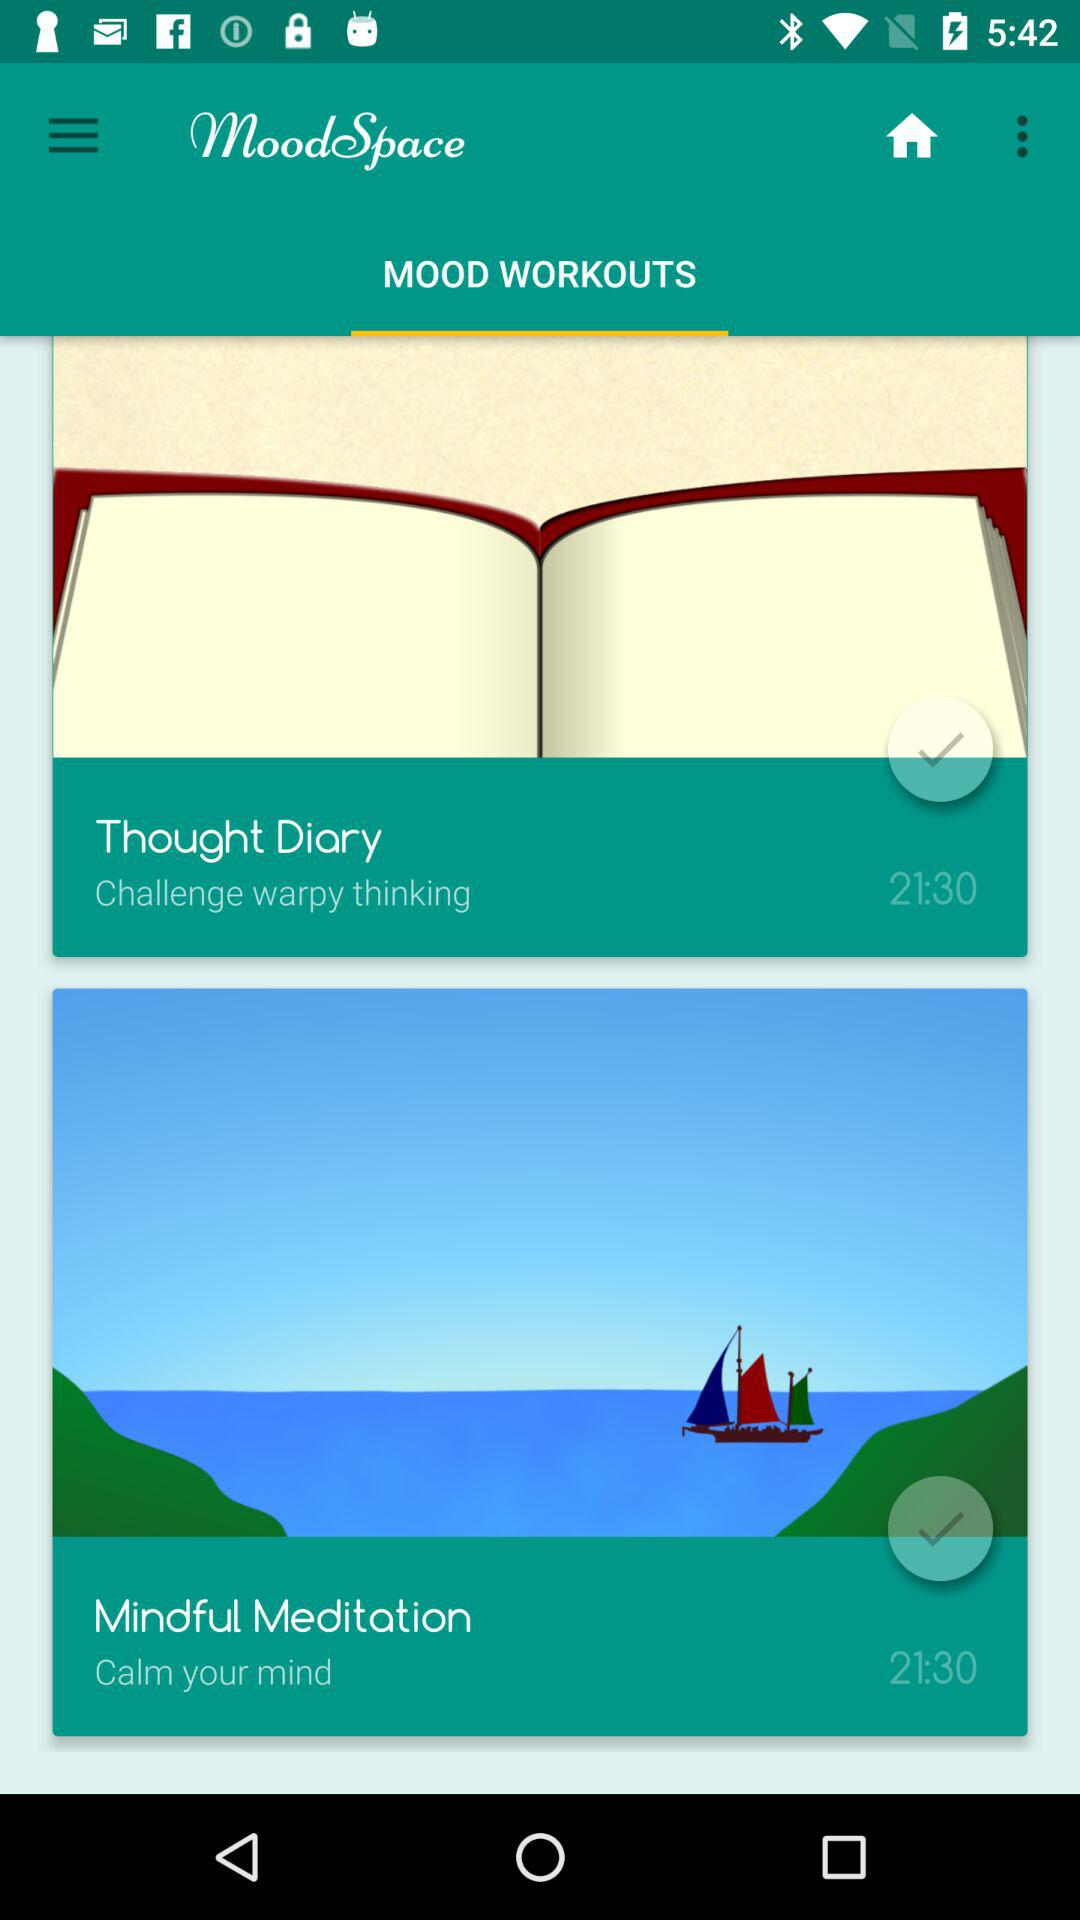What is the given timing? The given timing is 21:30. 